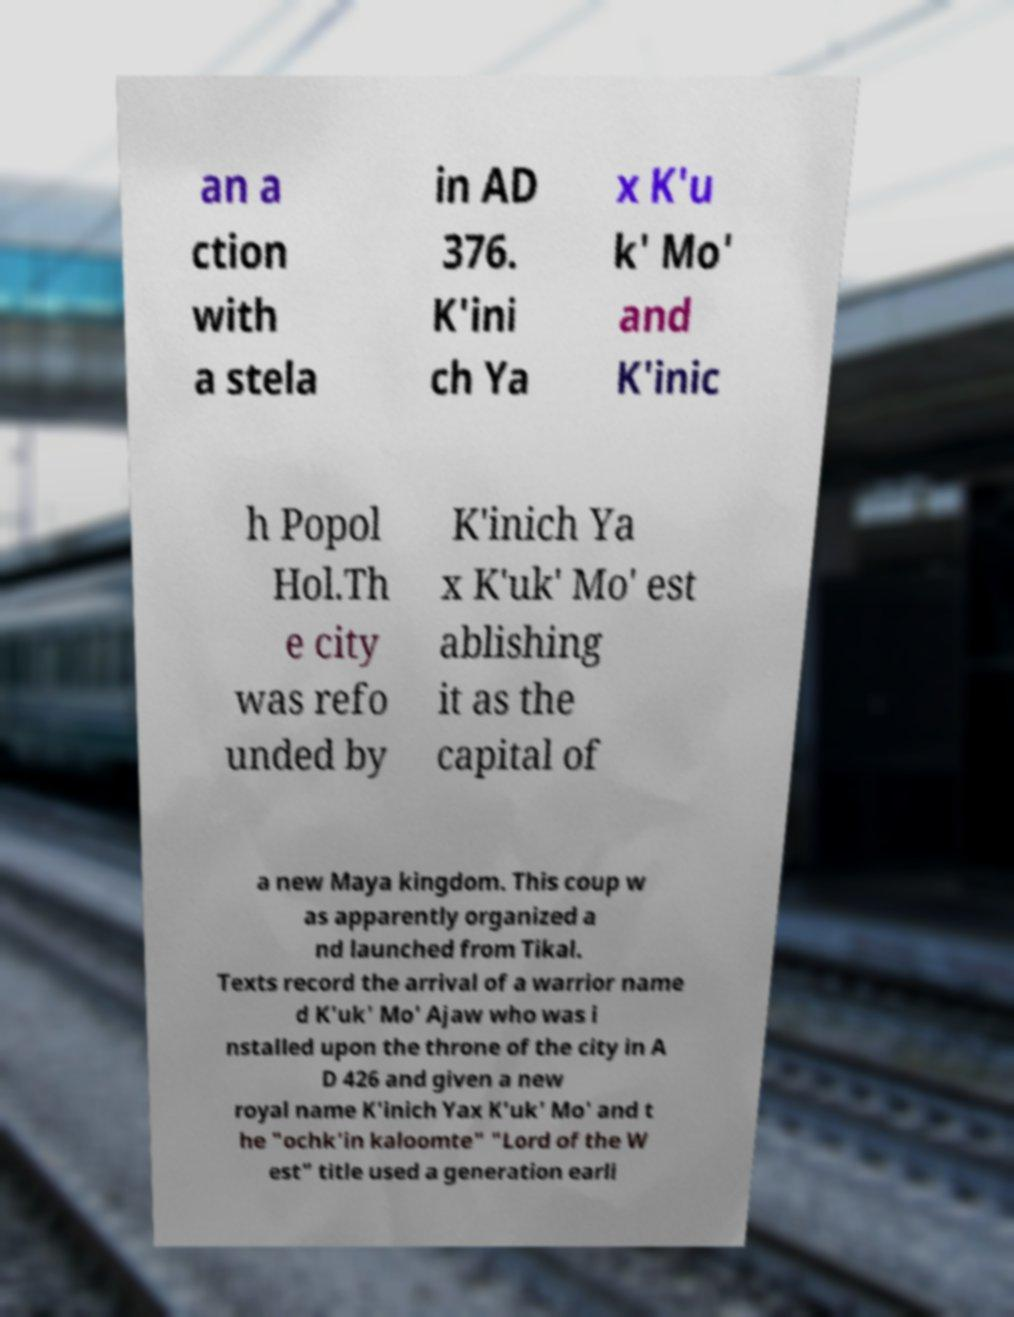I need the written content from this picture converted into text. Can you do that? an a ction with a stela in AD 376. K'ini ch Ya x K'u k' Mo' and K'inic h Popol Hol.Th e city was refo unded by K'inich Ya x K'uk' Mo' est ablishing it as the capital of a new Maya kingdom. This coup w as apparently organized a nd launched from Tikal. Texts record the arrival of a warrior name d K'uk' Mo' Ajaw who was i nstalled upon the throne of the city in A D 426 and given a new royal name K'inich Yax K'uk' Mo' and t he "ochk'in kaloomte" "Lord of the W est" title used a generation earli 